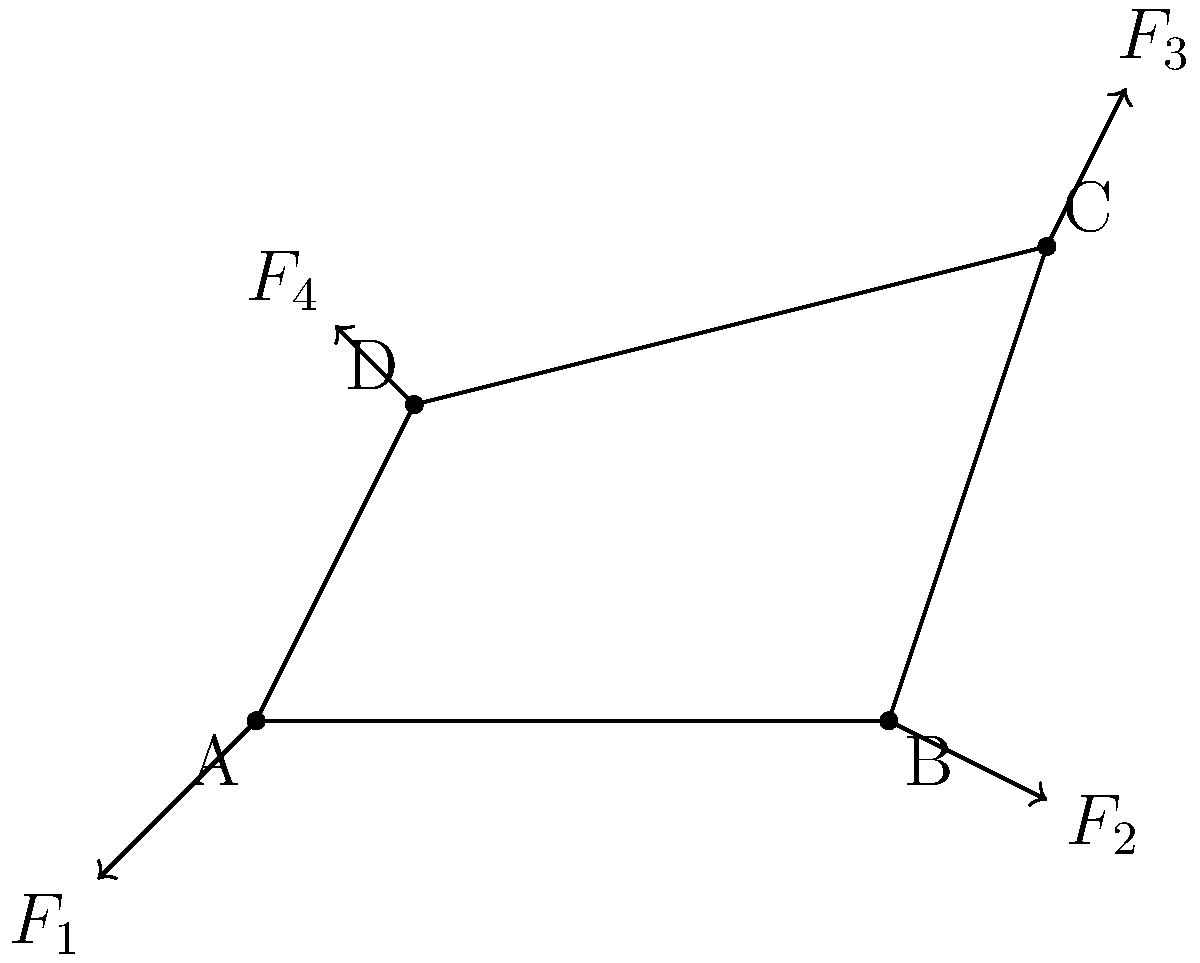Given a four-bar linkage mechanism ABCD as shown in the figure, with known forces $F_1$, $F_2$, $F_3$, and $F_4$ applied at points A, B, C, and D respectively, how would you approach determining the internal forces in each link using computational methods? Discuss the theoretical foundations and algorithmic approach you would employ. To determine the internal forces in each link of the four-bar linkage mechanism, we can apply the following computational approach based on the principles of static equilibrium and matrix operations:

1. Formulate equilibrium equations:
   For each joint (A, B, C, D), write force equilibrium equations in x and y directions.

2. Express unknown internal forces:
   Let $T_{AB}$, $T_{BC}$, $T_{CD}$, and $T_{DA}$ be the internal forces in each link.

3. Set up a system of linear equations:
   $$\begin{aligned}
   F_{1x} + T_{AB}\cos\theta_{AB} - T_{DA}\cos\theta_{DA} &= 0 \\
   F_{1y} + T_{AB}\sin\theta_{AB} - T_{DA}\sin\theta_{DA} &= 0 \\
   F_{2x} - T_{AB}\cos\theta_{AB} + T_{BC}\cos\theta_{BC} &= 0 \\
   F_{2y} - T_{AB}\sin\theta_{AB} + T_{BC}\sin\theta_{BC} &= 0 \\
   F_{3x} - T_{BC}\cos\theta_{BC} + T_{CD}\cos\theta_{CD} &= 0 \\
   F_{3y} - T_{BC}\sin\theta_{BC} + T_{CD}\sin\theta_{CD} &= 0 \\
   F_{4x} - T_{CD}\cos\theta_{CD} + T_{DA}\cos\theta_{DA} &= 0 \\
   F_{4y} - T_{CD}\sin\theta_{CD} + T_{DA}\sin\theta_{DA} &= 0
   \end{aligned}$$

4. Represent as a matrix equation:
   $\mathbf{A}\mathbf{x} = \mathbf{b}$, where $\mathbf{A}$ is the coefficient matrix, $\mathbf{x}$ is the vector of unknown internal forces, and $\mathbf{b}$ is the vector of known external forces.

5. Solve the system:
   Use computational methods like Gaussian elimination or LU decomposition to solve for $\mathbf{x}$.

6. Implement the algorithm:
   Write a program (e.g., in Python or MATLAB) to:
   a. Input mechanism geometry and external forces
   b. Construct the coefficient matrix and force vector
   c. Solve the system of equations
   d. Output the internal forces

7. Validate results:
   Check if the solution satisfies equilibrium conditions at each joint.

This approach leverages the theoretical foundations of static equilibrium in planar systems and linear algebra, combined with computational methods for solving systems of linear equations efficiently.
Answer: Formulate equilibrium equations, express as a matrix equation $\mathbf{A}\mathbf{x} = \mathbf{b}$, solve computationally using linear algebra methods. 